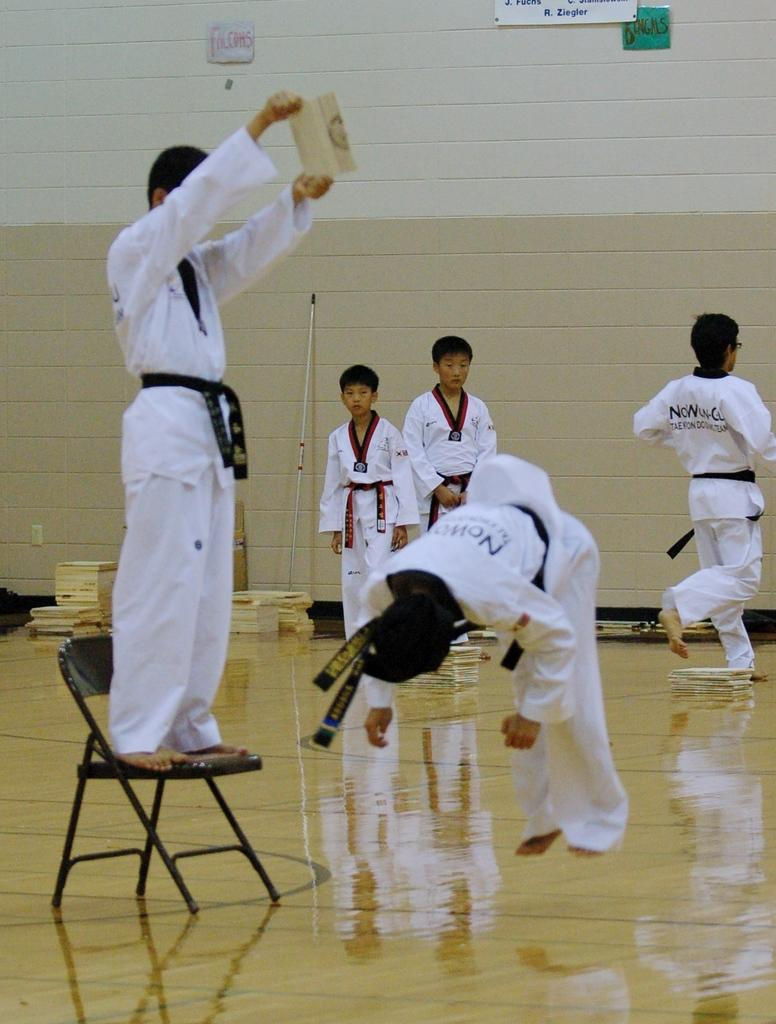What is the main action being performed by the person in the center of the image? There is a person jumping in the center of the image. What is the position of the person on the left side of the image? There is a person standing on a chair on the left side of the image. Can you describe the background of the image? There are persons visible in the background of the image, and there is a wall in the background as well. What type of creature is being pulled by the person in the image? There is no creature being pulled in the image; the person is jumping and another person is standing on a chair. 